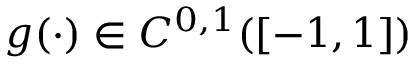<formula> <loc_0><loc_0><loc_500><loc_500>g ( \cdot ) \in C ^ { 0 , 1 } ( [ - 1 , 1 ] )</formula> 